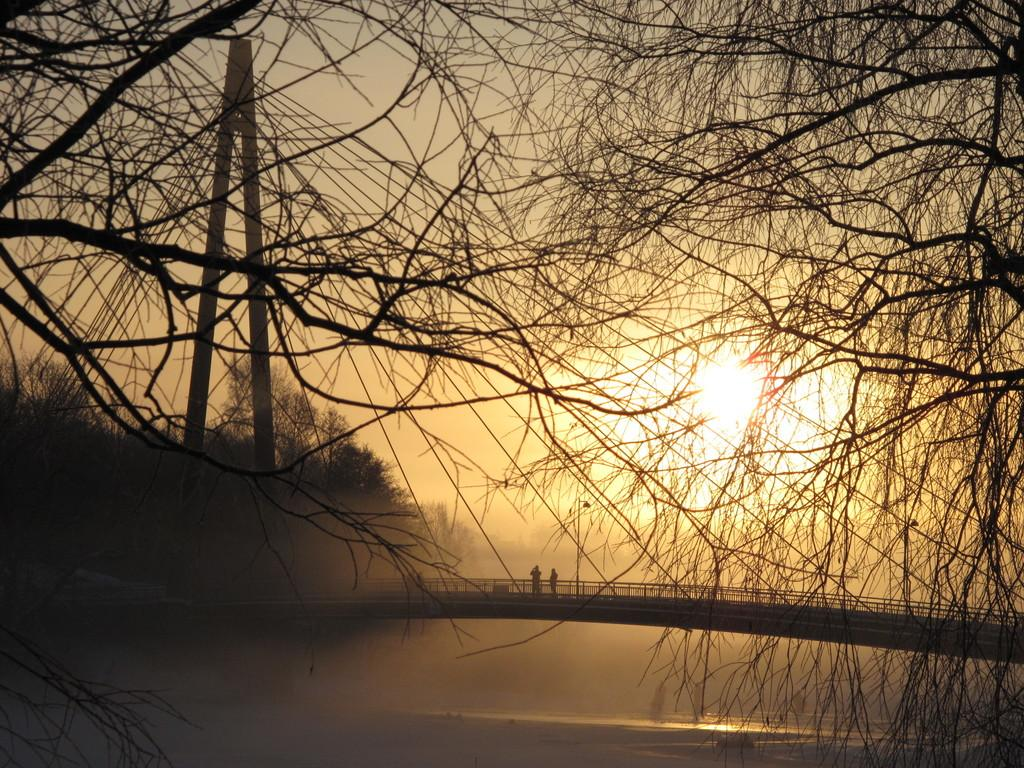What structure is present in the image? There is a bridge in the image. Who or what is on the bridge? Two persons are standing on the bridge. What can be seen in the background of the image? There are trees, lights, water, and the sun visible in the background of the image. What type of fruit is being used by the writer in the image? There is no writer or fruit present in the image. 